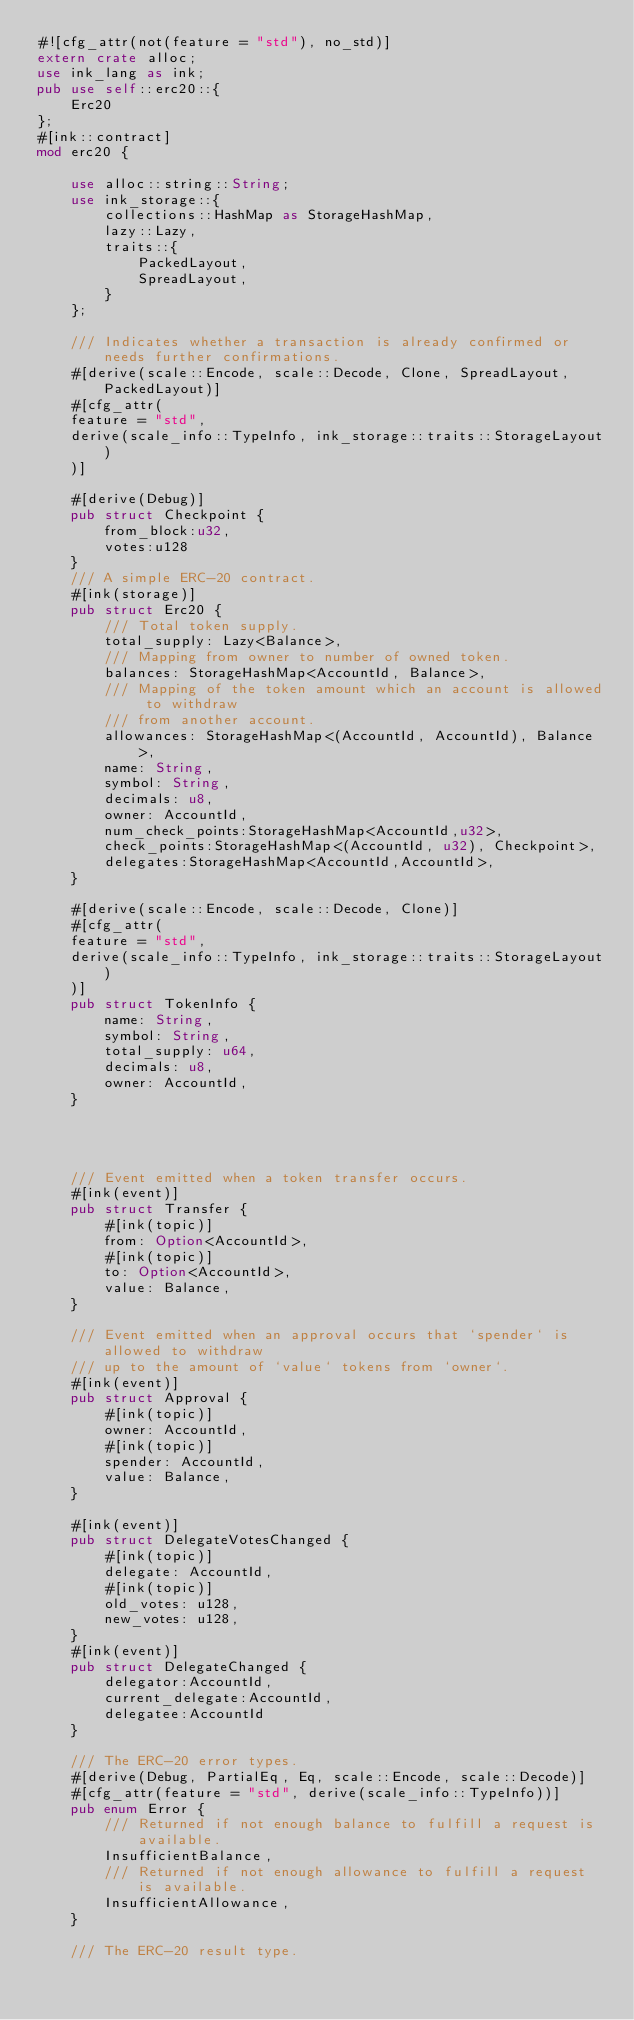<code> <loc_0><loc_0><loc_500><loc_500><_Rust_>#![cfg_attr(not(feature = "std"), no_std)]
extern crate alloc;
use ink_lang as ink;
pub use self::erc20::{
    Erc20
};
#[ink::contract]
mod erc20 {

    use alloc::string::String;
    use ink_storage::{
        collections::HashMap as StorageHashMap,
        lazy::Lazy,
        traits::{
            PackedLayout,
            SpreadLayout,
        }
    };

    /// Indicates whether a transaction is already confirmed or needs further confirmations.
    #[derive(scale::Encode, scale::Decode, Clone, SpreadLayout, PackedLayout)]
    #[cfg_attr(
    feature = "std",
    derive(scale_info::TypeInfo, ink_storage::traits::StorageLayout)
    )]

    #[derive(Debug)]
    pub struct Checkpoint {
        from_block:u32,
        votes:u128
    }
    /// A simple ERC-20 contract.
    #[ink(storage)]
    pub struct Erc20 {
        /// Total token supply.
        total_supply: Lazy<Balance>,
        /// Mapping from owner to number of owned token.
        balances: StorageHashMap<AccountId, Balance>,
        /// Mapping of the token amount which an account is allowed to withdraw
        /// from another account.
        allowances: StorageHashMap<(AccountId, AccountId), Balance>,
        name: String,
        symbol: String,
        decimals: u8,
        owner: AccountId,
        num_check_points:StorageHashMap<AccountId,u32>,
        check_points:StorageHashMap<(AccountId, u32), Checkpoint>,
        delegates:StorageHashMap<AccountId,AccountId>,
    }

    #[derive(scale::Encode, scale::Decode, Clone)]
    #[cfg_attr(
    feature = "std",
    derive(scale_info::TypeInfo, ink_storage::traits::StorageLayout)
    )]
    pub struct TokenInfo {
        name: String,
        symbol: String,
        total_supply: u64,
        decimals: u8,
        owner: AccountId,
    }




    /// Event emitted when a token transfer occurs.
    #[ink(event)]
    pub struct Transfer {
        #[ink(topic)]
        from: Option<AccountId>,
        #[ink(topic)]
        to: Option<AccountId>,
        value: Balance,
    }

    /// Event emitted when an approval occurs that `spender` is allowed to withdraw
    /// up to the amount of `value` tokens from `owner`.
    #[ink(event)]
    pub struct Approval {
        #[ink(topic)]
        owner: AccountId,
        #[ink(topic)]
        spender: AccountId,
        value: Balance,
    }

    #[ink(event)]
    pub struct DelegateVotesChanged {
        #[ink(topic)]
        delegate: AccountId,
        #[ink(topic)]
        old_votes: u128,
        new_votes: u128,
    }
    #[ink(event)]
    pub struct DelegateChanged {
        delegator:AccountId,
        current_delegate:AccountId,
        delegatee:AccountId
    }

    /// The ERC-20 error types.
    #[derive(Debug, PartialEq, Eq, scale::Encode, scale::Decode)]
    #[cfg_attr(feature = "std", derive(scale_info::TypeInfo))]
    pub enum Error {
        /// Returned if not enough balance to fulfill a request is available.
        InsufficientBalance,
        /// Returned if not enough allowance to fulfill a request is available.
        InsufficientAllowance,
    }

    /// The ERC-20 result type.</code> 